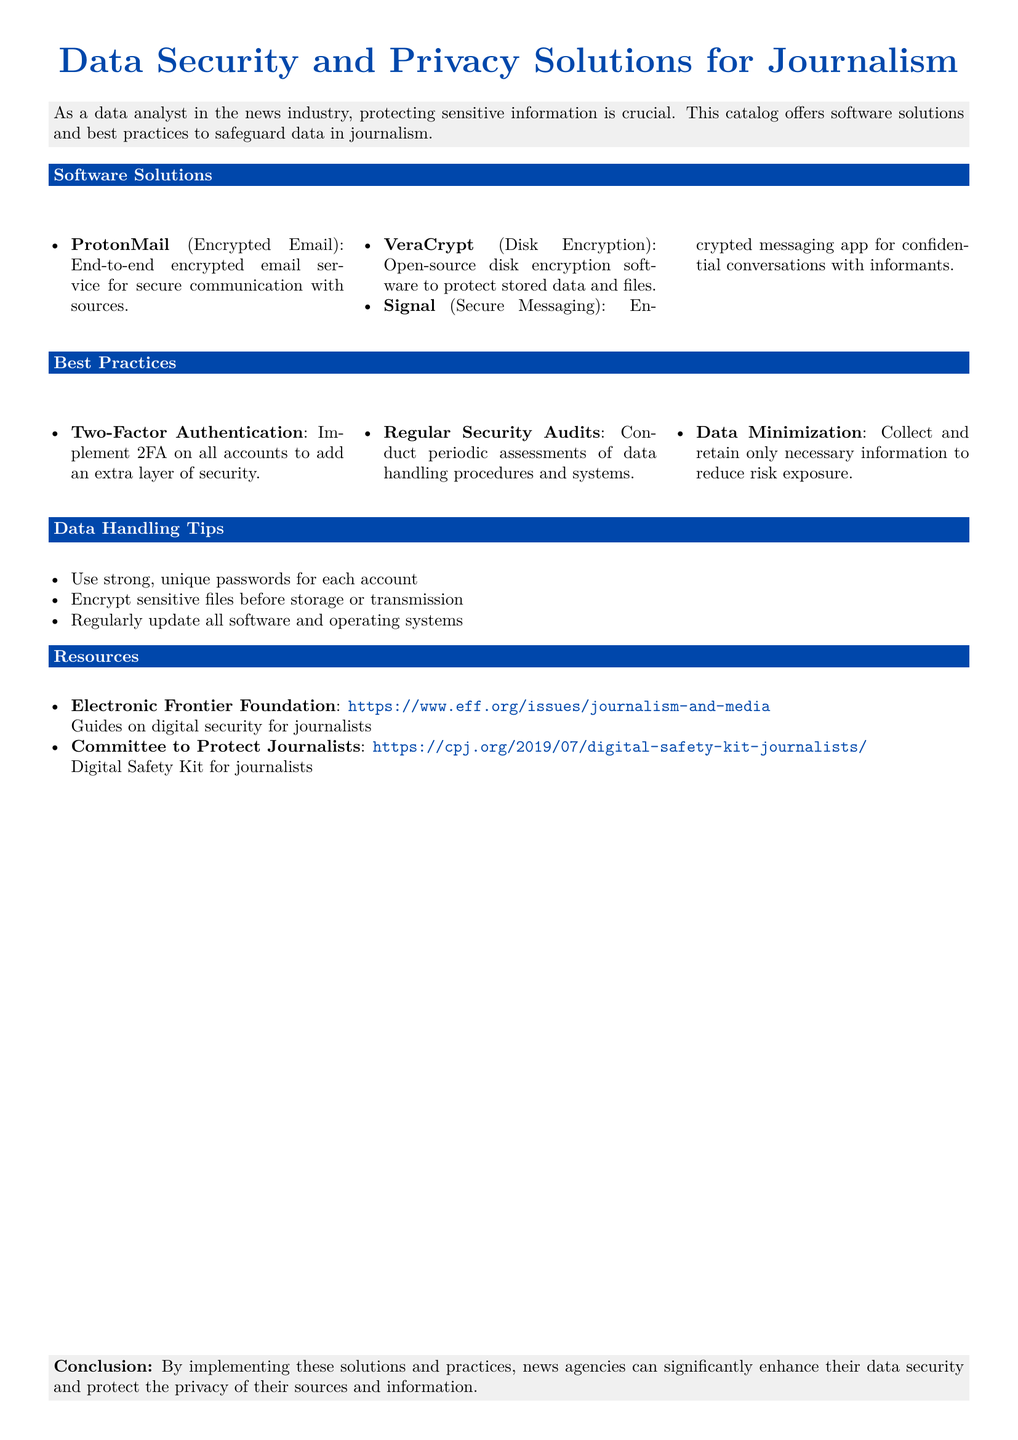what is the purpose of the catalog? The catalog offers software solutions and best practices to safeguard data in journalism.
Answer: safeguard data in journalism name one software solution listed for encrypted email. The document lists ProtonMail as an encrypted email solution.
Answer: ProtonMail how many software solutions are mentioned in the document? There are three software solutions mentioned in the document.
Answer: 3 what is one best practice for enhancing data security? The document mentions implementing Two-Factor Authentication as a best practice.
Answer: Two-Factor Authentication which organization provides guides on digital security for journalists? The document states that the Electronic Frontier Foundation offers guides on this topic.
Answer: Electronic Frontier Foundation what is a key recommendation under Data Handling Tips? Strong, unique passwords for each account is recommended in the Data Handling Tips.
Answer: strong, unique passwords how many resources are listed in the document? The document lists two resources for journalists.
Answer: 2 what type of encryption does VeraCrypt provide? VeraCrypt provides disk encryption as described in the document.
Answer: Disk Encryption what is the conclusion regarding data security practices? The conclusion states that implementing these solutions significantly enhances data security.
Answer: enhance data security 